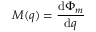Convert formula to latex. <formula><loc_0><loc_0><loc_500><loc_500>M ( q ) = { \frac { d \Phi _ { m } } { d q } }</formula> 